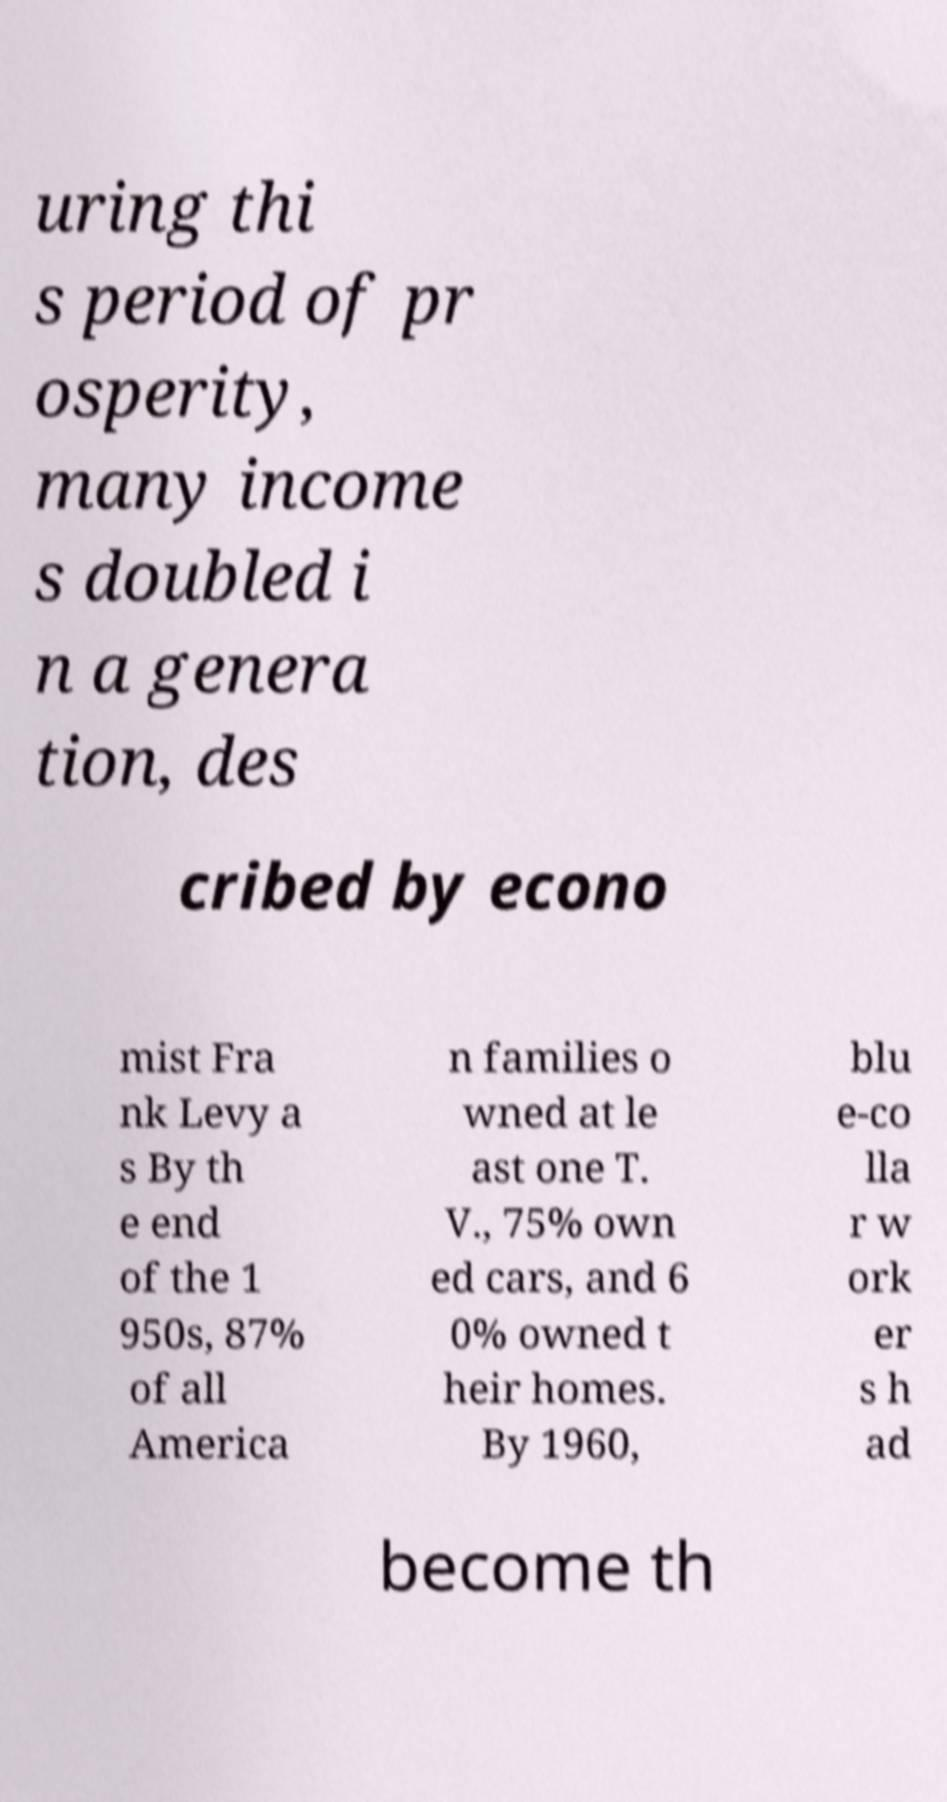Could you assist in decoding the text presented in this image and type it out clearly? uring thi s period of pr osperity, many income s doubled i n a genera tion, des cribed by econo mist Fra nk Levy a s By th e end of the 1 950s, 87% of all America n families o wned at le ast one T. V., 75% own ed cars, and 6 0% owned t heir homes. By 1960, blu e-co lla r w ork er s h ad become th 